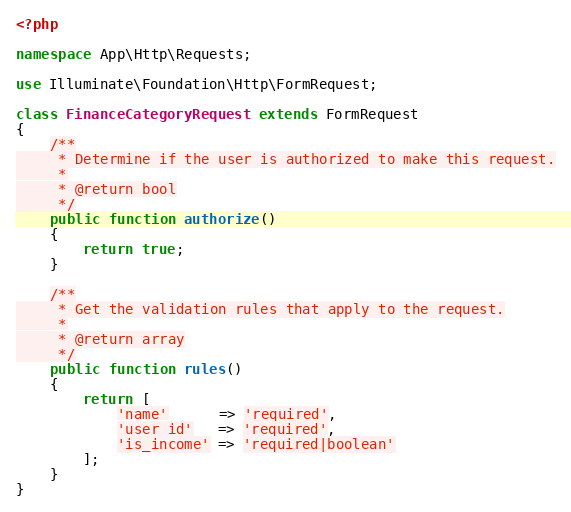<code> <loc_0><loc_0><loc_500><loc_500><_PHP_><?php

namespace App\Http\Requests;

use Illuminate\Foundation\Http\FormRequest;

class FinanceCategoryRequest extends FormRequest
{
    /**
     * Determine if the user is authorized to make this request.
     *
     * @return bool
     */
    public function authorize()
    {
        return true;
    }

    /**
     * Get the validation rules that apply to the request.
     *
     * @return array
     */
    public function rules()
    {
        return [
            'name'      => 'required',
            'user_id'   => 'required',
            'is_income' => 'required|boolean'
        ];
    }
}
</code> 